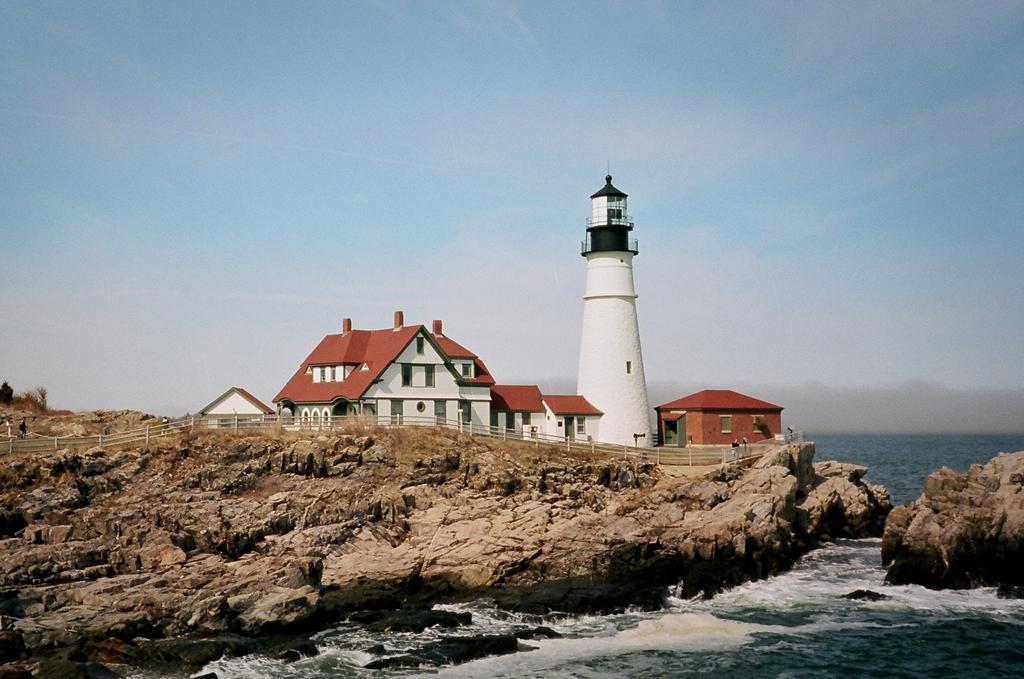How would you summarize this image in a sentence or two? In the foreground of this image, there is water and rocks. In the middle, there is a railing, lighthouse and buildings. At the top, there is the sky. 